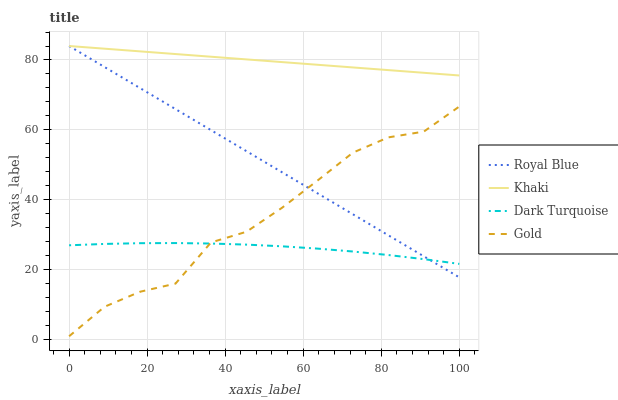Does Dark Turquoise have the minimum area under the curve?
Answer yes or no. Yes. Does Khaki have the maximum area under the curve?
Answer yes or no. Yes. Does Gold have the minimum area under the curve?
Answer yes or no. No. Does Gold have the maximum area under the curve?
Answer yes or no. No. Is Royal Blue the smoothest?
Answer yes or no. Yes. Is Gold the roughest?
Answer yes or no. Yes. Is Khaki the smoothest?
Answer yes or no. No. Is Khaki the roughest?
Answer yes or no. No. Does Gold have the lowest value?
Answer yes or no. Yes. Does Khaki have the lowest value?
Answer yes or no. No. Does Khaki have the highest value?
Answer yes or no. Yes. Does Gold have the highest value?
Answer yes or no. No. Is Gold less than Khaki?
Answer yes or no. Yes. Is Khaki greater than Dark Turquoise?
Answer yes or no. Yes. Does Royal Blue intersect Dark Turquoise?
Answer yes or no. Yes. Is Royal Blue less than Dark Turquoise?
Answer yes or no. No. Is Royal Blue greater than Dark Turquoise?
Answer yes or no. No. Does Gold intersect Khaki?
Answer yes or no. No. 